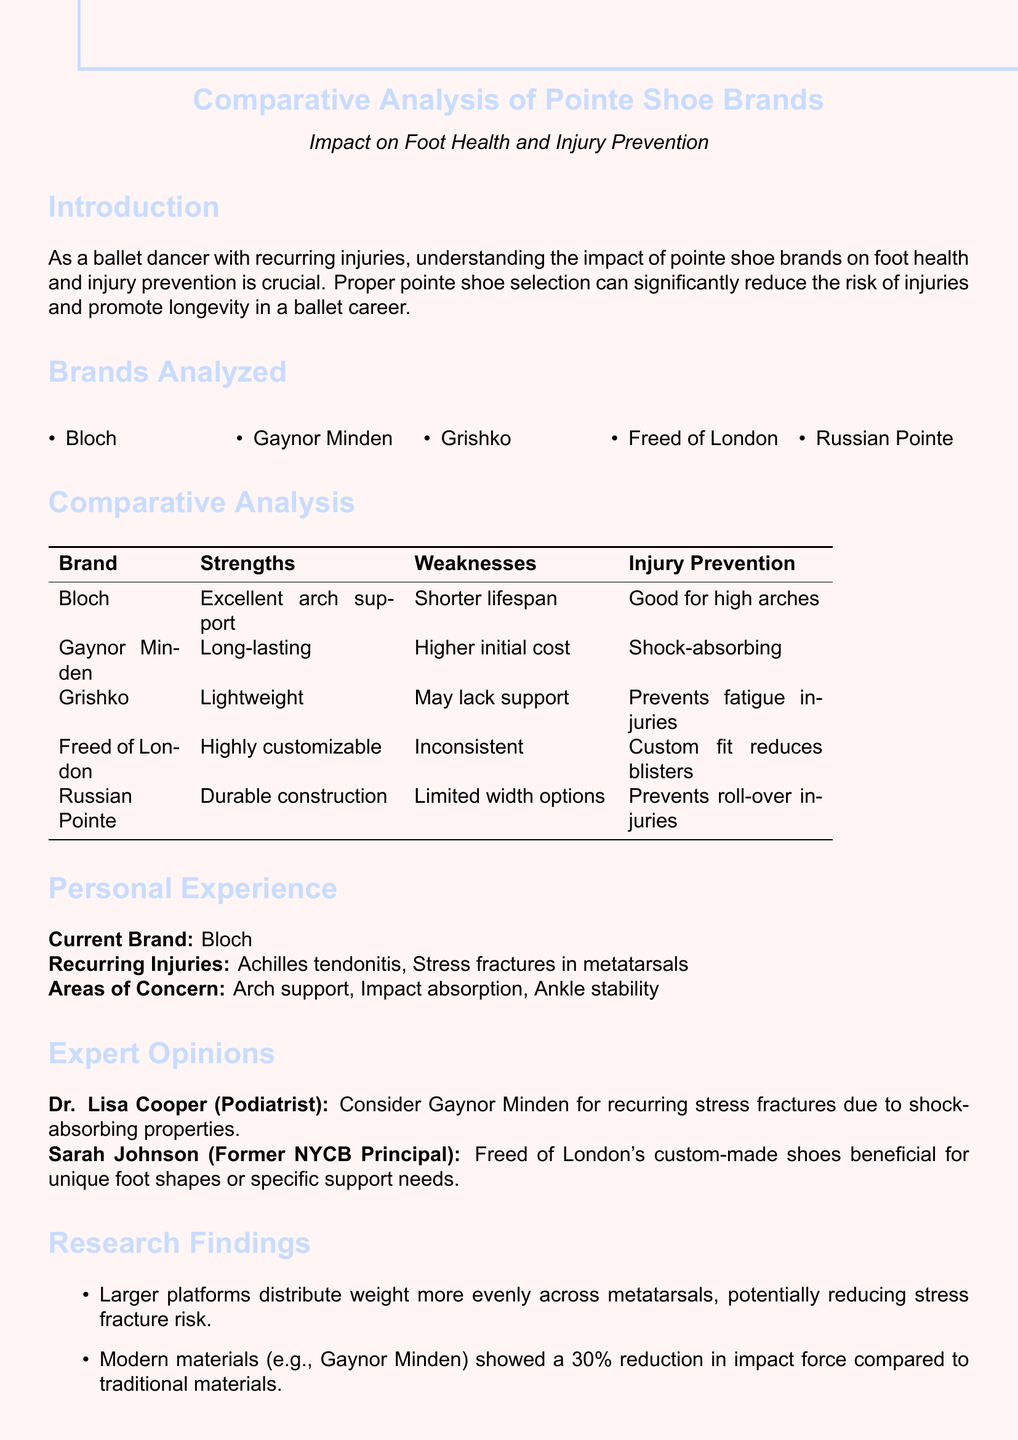What is the primary focus of the memo? The memo focuses on analyzing the impact of different pointe shoe brands on foot health and injury prevention for ballet dancers.
Answer: impact on foot health and injury prevention Which pointe shoe brand offers excellent arch support? The document highlights Bloch as providing excellent arch support among the analyzed brands.
Answer: Bloch What is one strength of Gaynor Minden shoes? The strengths of Gaynor Minden shoes are discussed, indicating they are long-lasting.
Answer: Long-lasting Which injury is mentioned as a recurring issue? The memo lists Achilles tendonitis as one of the recurring injuries faced by the dancer.
Answer: Achilles tendonitis What expert recommends Gaynor Minden? Dr. Lisa Cooper, a podiatrist, recommends Gaynor Minden for dancers with recurring stress fractures.
Answer: Dr. Lisa Cooper What is the weakness of Freed of London shoes? The document states that Freed of London shoes have an inconsistency due to their handmade nature.
Answer: Inconsistent How much reduction in impact force do modern materials provide? According to the document, modern materials used in brands like Gaynor Minden showed a 30 percent reduction in impact force.
Answer: 30 percent Which brand is recommended for custom fit? The memo identifies Freed of London as a brand that offers custom-made shoes beneficial for unique foot shapes.
Answer: Freed of London 